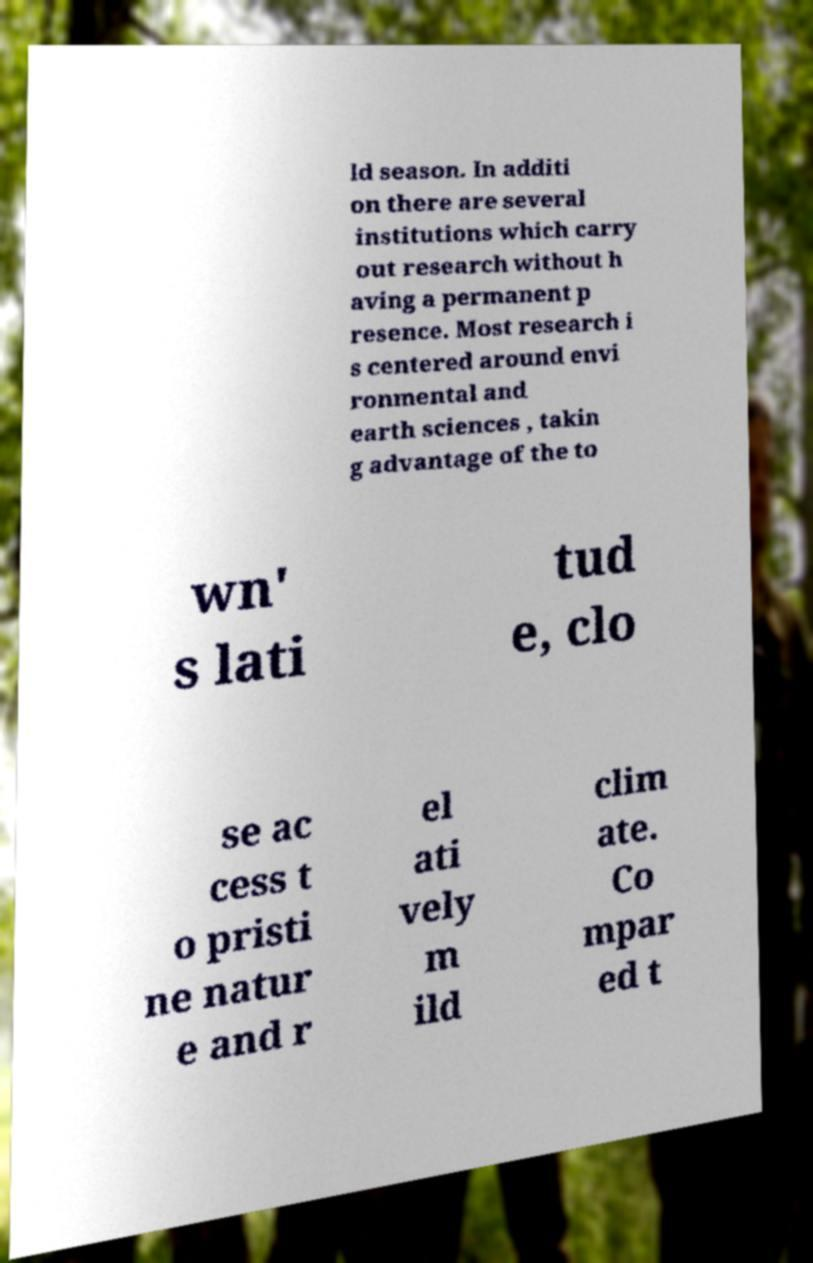There's text embedded in this image that I need extracted. Can you transcribe it verbatim? ld season. In additi on there are several institutions which carry out research without h aving a permanent p resence. Most research i s centered around envi ronmental and earth sciences , takin g advantage of the to wn' s lati tud e, clo se ac cess t o pristi ne natur e and r el ati vely m ild clim ate. Co mpar ed t 